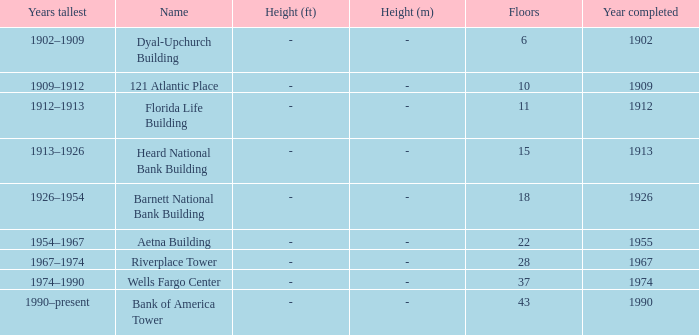How tall is the florida life building, completed before 1990? -foot (m). 